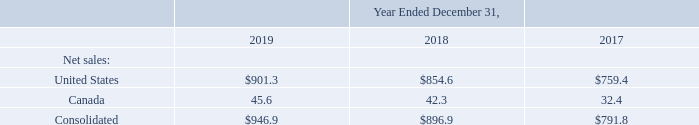Disaggregation of Revenues
The Company serves customers in diverse geographies, which are subject to different economic and industry factors. The Company's presentation of revenue by geography most reasonably depicts how the nature, amount, timing and uncertainty of Company revenue and cash flows are affected by economic and industry factors. The following table presents the Company's revenue, from continuing operations, by geography for the year ended December 31, 2019, 2018 and 2017 (in millions):
What does the company's presentation of revenue by geography depict? How the nature, amount, timing and uncertainty of company revenue and cash flows are affected by economic and industry factors. What is the company's revenue from continuing operations in 2018 and 2019 respectively?
Answer scale should be: million. $896.9, $946.9. What is the company's revenue from continuing operations in 2018 and 2017 respectively?
Answer scale should be: million. $896.9, $791.8. What is the company's total revenue from continuing operations in 2018 and 2019?
Answer scale should be: million. 946.9 + 896.9 
Answer: 1843.8. What is the company's total revenue from continuing operations in 2018 and 2017?
Answer scale should be: million. 791.8 + 896.9 
Answer: 1688.7. What is the percentage change in the company's revenue from continuing operations between 2018 and 2019?
Answer scale should be: percent. (946.9 - 896.9)/896.9 
Answer: 5.57. 